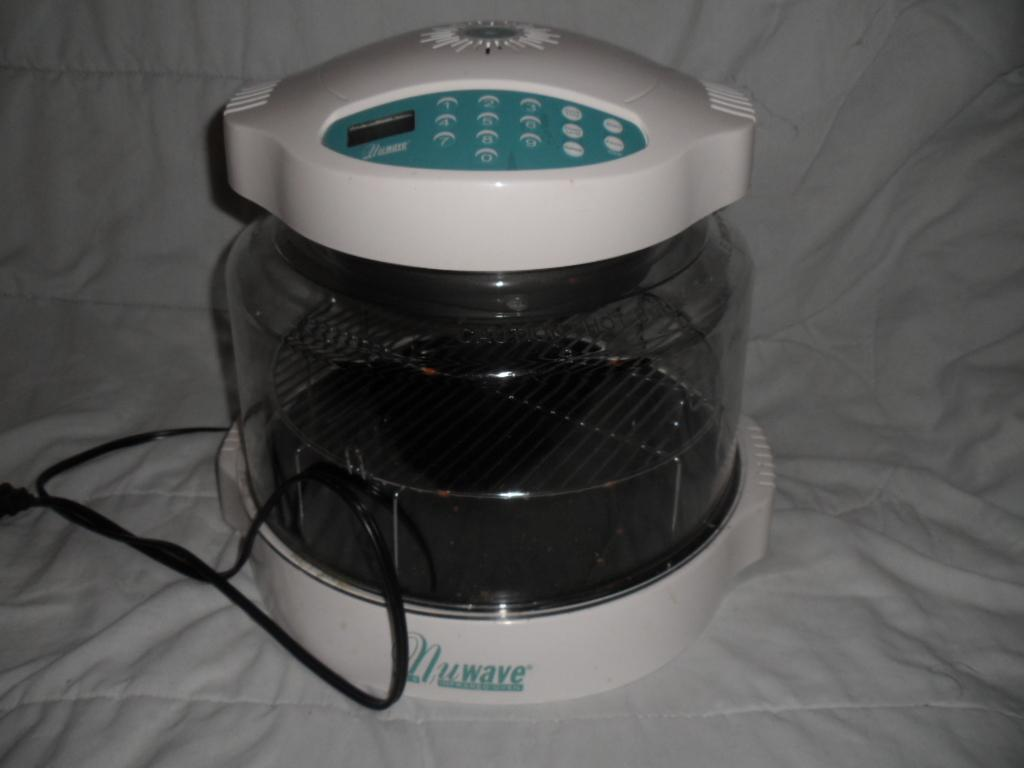Provide a one-sentence caption for the provided image. A Nuwave electronic device on a white blanket. 